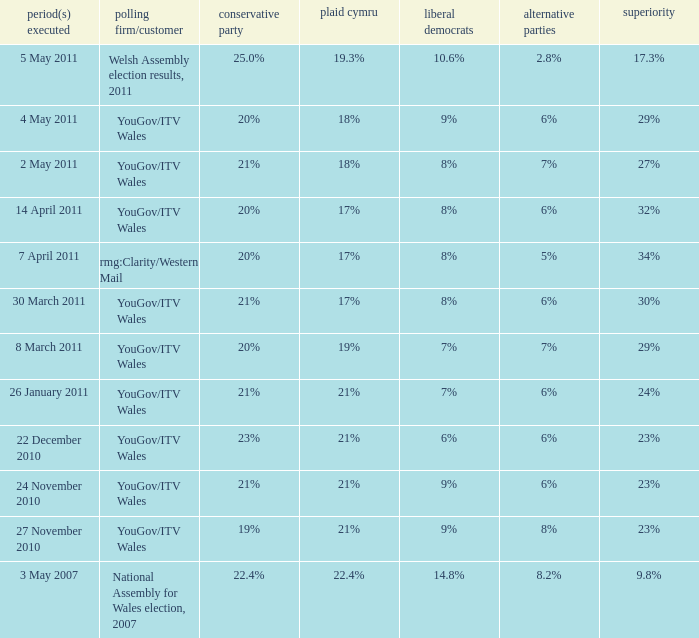I want the plaid cymru for Polling organisation/client of yougov/itv wales for 4 may 2011 18%. Parse the full table. {'header': ['period(s) executed', 'polling firm/customer', 'conservative party', 'plaid cymru', 'liberal democrats', 'alternative parties', 'superiority'], 'rows': [['5 May 2011', 'Welsh Assembly election results, 2011', '25.0%', '19.3%', '10.6%', '2.8%', '17.3%'], ['4 May 2011', 'YouGov/ITV Wales', '20%', '18%', '9%', '6%', '29%'], ['2 May 2011', 'YouGov/ITV Wales', '21%', '18%', '8%', '7%', '27%'], ['14 April 2011', 'YouGov/ITV Wales', '20%', '17%', '8%', '6%', '32%'], ['7 April 2011', 'rmg:Clarity/Western Mail', '20%', '17%', '8%', '5%', '34%'], ['30 March 2011', 'YouGov/ITV Wales', '21%', '17%', '8%', '6%', '30%'], ['8 March 2011', 'YouGov/ITV Wales', '20%', '19%', '7%', '7%', '29%'], ['26 January 2011', 'YouGov/ITV Wales', '21%', '21%', '7%', '6%', '24%'], ['22 December 2010', 'YouGov/ITV Wales', '23%', '21%', '6%', '6%', '23%'], ['24 November 2010', 'YouGov/ITV Wales', '21%', '21%', '9%', '6%', '23%'], ['27 November 2010', 'YouGov/ITV Wales', '19%', '21%', '9%', '8%', '23%'], ['3 May 2007', 'National Assembly for Wales election, 2007', '22.4%', '22.4%', '14.8%', '8.2%', '9.8%']]} 